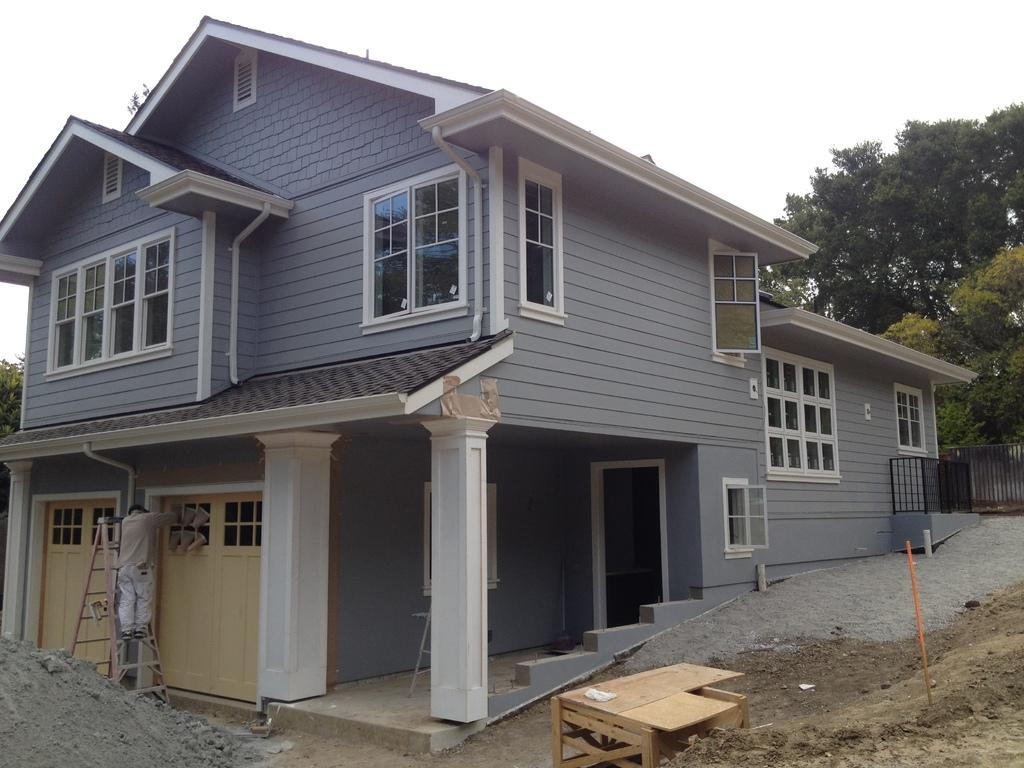What features can be seen on the house in the image? The house has windows and doors. What can be seen in the background of the image? There are trees and a fence in the background. What piece of furniture is beside the house? There is a table beside the house. What object is in front of the house? There is a ladder in front of the house. Is there a person present in the image? Yes, there is a person in front of the house. What type of bait is the squirrel using to attack the house in the image? There is no squirrel present in the image, and therefore no attack or bait can be observed. 